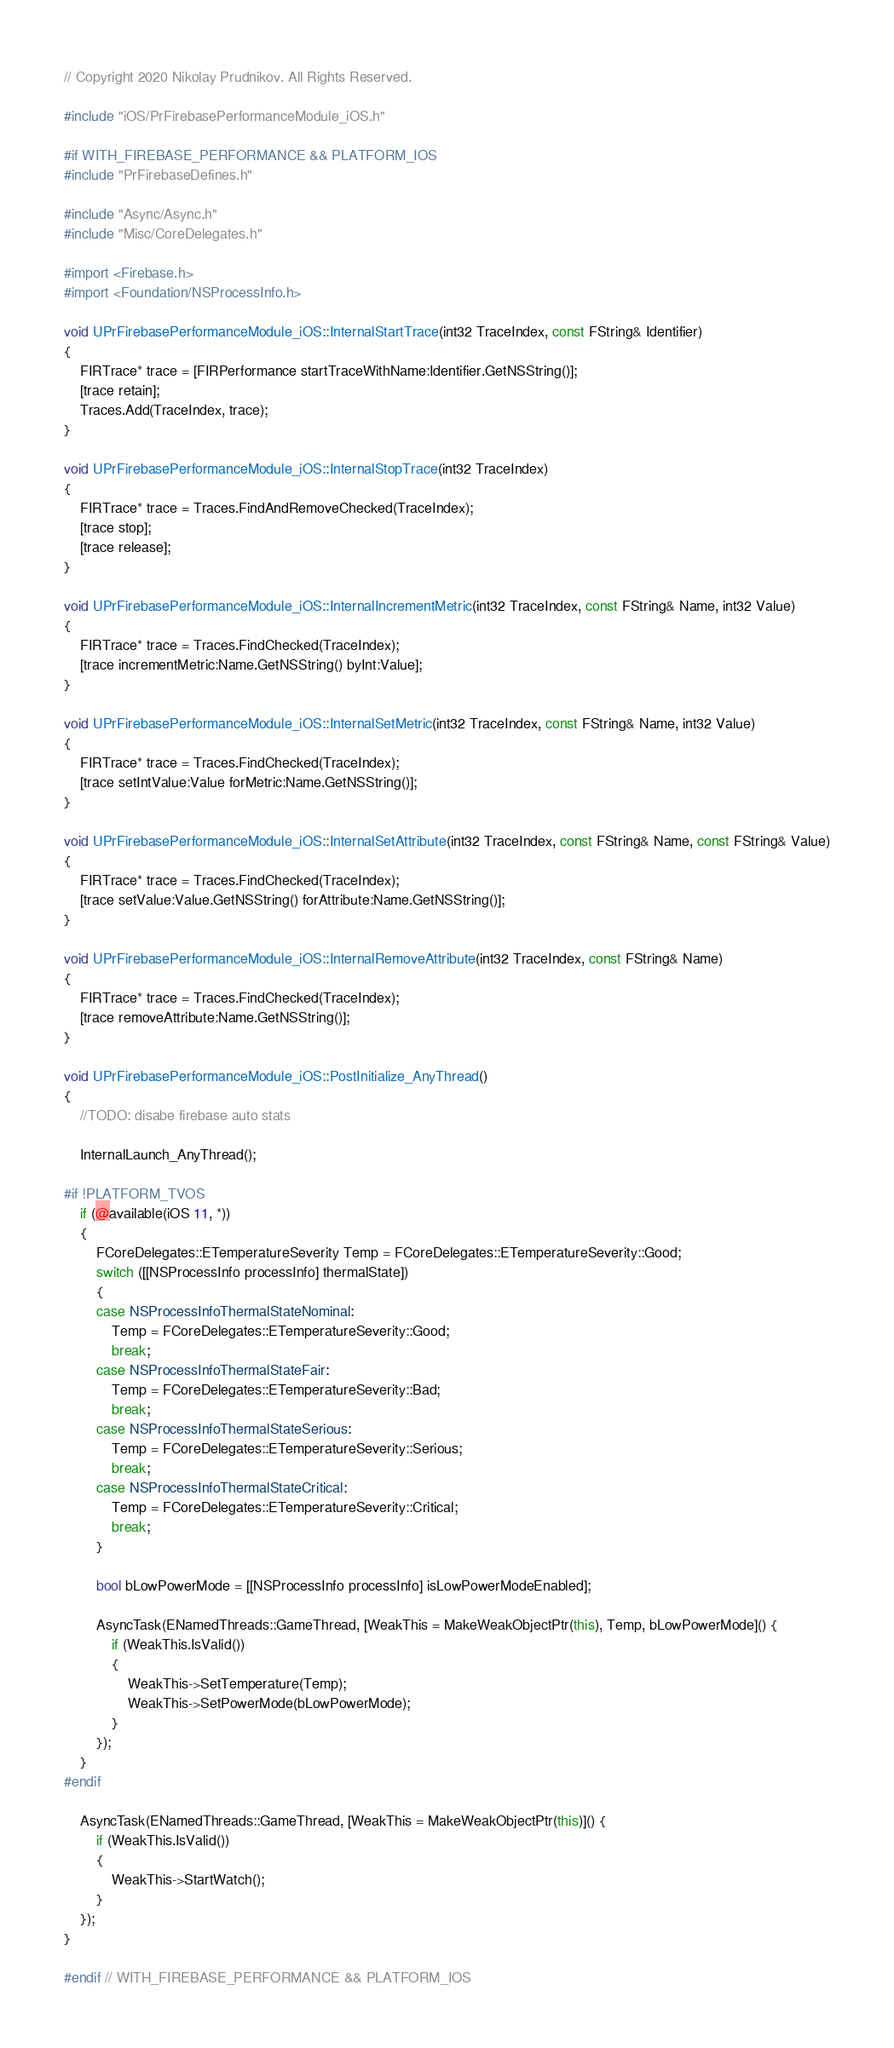Convert code to text. <code><loc_0><loc_0><loc_500><loc_500><_C++_>// Copyright 2020 Nikolay Prudnikov. All Rights Reserved.

#include "iOS/PrFirebasePerformanceModule_iOS.h"

#if WITH_FIREBASE_PERFORMANCE && PLATFORM_IOS
#include "PrFirebaseDefines.h"

#include "Async/Async.h"
#include "Misc/CoreDelegates.h"

#import <Firebase.h>
#import <Foundation/NSProcessInfo.h>

void UPrFirebasePerformanceModule_iOS::InternalStartTrace(int32 TraceIndex, const FString& Identifier)
{
	FIRTrace* trace = [FIRPerformance startTraceWithName:Identifier.GetNSString()];
	[trace retain];
	Traces.Add(TraceIndex, trace);
}

void UPrFirebasePerformanceModule_iOS::InternalStopTrace(int32 TraceIndex)
{
	FIRTrace* trace = Traces.FindAndRemoveChecked(TraceIndex);
	[trace stop];
	[trace release];
}

void UPrFirebasePerformanceModule_iOS::InternalIncrementMetric(int32 TraceIndex, const FString& Name, int32 Value)
{
	FIRTrace* trace = Traces.FindChecked(TraceIndex);
	[trace incrementMetric:Name.GetNSString() byInt:Value];
}

void UPrFirebasePerformanceModule_iOS::InternalSetMetric(int32 TraceIndex, const FString& Name, int32 Value)
{
	FIRTrace* trace = Traces.FindChecked(TraceIndex);
	[trace setIntValue:Value forMetric:Name.GetNSString()];
}

void UPrFirebasePerformanceModule_iOS::InternalSetAttribute(int32 TraceIndex, const FString& Name, const FString& Value)
{
	FIRTrace* trace = Traces.FindChecked(TraceIndex);
	[trace setValue:Value.GetNSString() forAttribute:Name.GetNSString()];
}

void UPrFirebasePerformanceModule_iOS::InternalRemoveAttribute(int32 TraceIndex, const FString& Name)
{
	FIRTrace* trace = Traces.FindChecked(TraceIndex);
	[trace removeAttribute:Name.GetNSString()];
}

void UPrFirebasePerformanceModule_iOS::PostInitialize_AnyThread()
{
	//TODO: disabe firebase auto stats

	InternalLaunch_AnyThread();

#if !PLATFORM_TVOS
	if (@available(iOS 11, *))
	{
		FCoreDelegates::ETemperatureSeverity Temp = FCoreDelegates::ETemperatureSeverity::Good;
		switch ([[NSProcessInfo processInfo] thermalState])
		{
		case NSProcessInfoThermalStateNominal:
			Temp = FCoreDelegates::ETemperatureSeverity::Good;
			break;
		case NSProcessInfoThermalStateFair:
			Temp = FCoreDelegates::ETemperatureSeverity::Bad;
			break;
		case NSProcessInfoThermalStateSerious:
			Temp = FCoreDelegates::ETemperatureSeverity::Serious;
			break;
		case NSProcessInfoThermalStateCritical:
			Temp = FCoreDelegates::ETemperatureSeverity::Critical;
			break;
		}

		bool bLowPowerMode = [[NSProcessInfo processInfo] isLowPowerModeEnabled];

		AsyncTask(ENamedThreads::GameThread, [WeakThis = MakeWeakObjectPtr(this), Temp, bLowPowerMode]() {
			if (WeakThis.IsValid())
			{
				WeakThis->SetTemperature(Temp);
				WeakThis->SetPowerMode(bLowPowerMode);
			}
		});
	}
#endif

	AsyncTask(ENamedThreads::GameThread, [WeakThis = MakeWeakObjectPtr(this)]() {
		if (WeakThis.IsValid())
		{
			WeakThis->StartWatch();
		}
	});
}

#endif // WITH_FIREBASE_PERFORMANCE && PLATFORM_IOS
</code> 